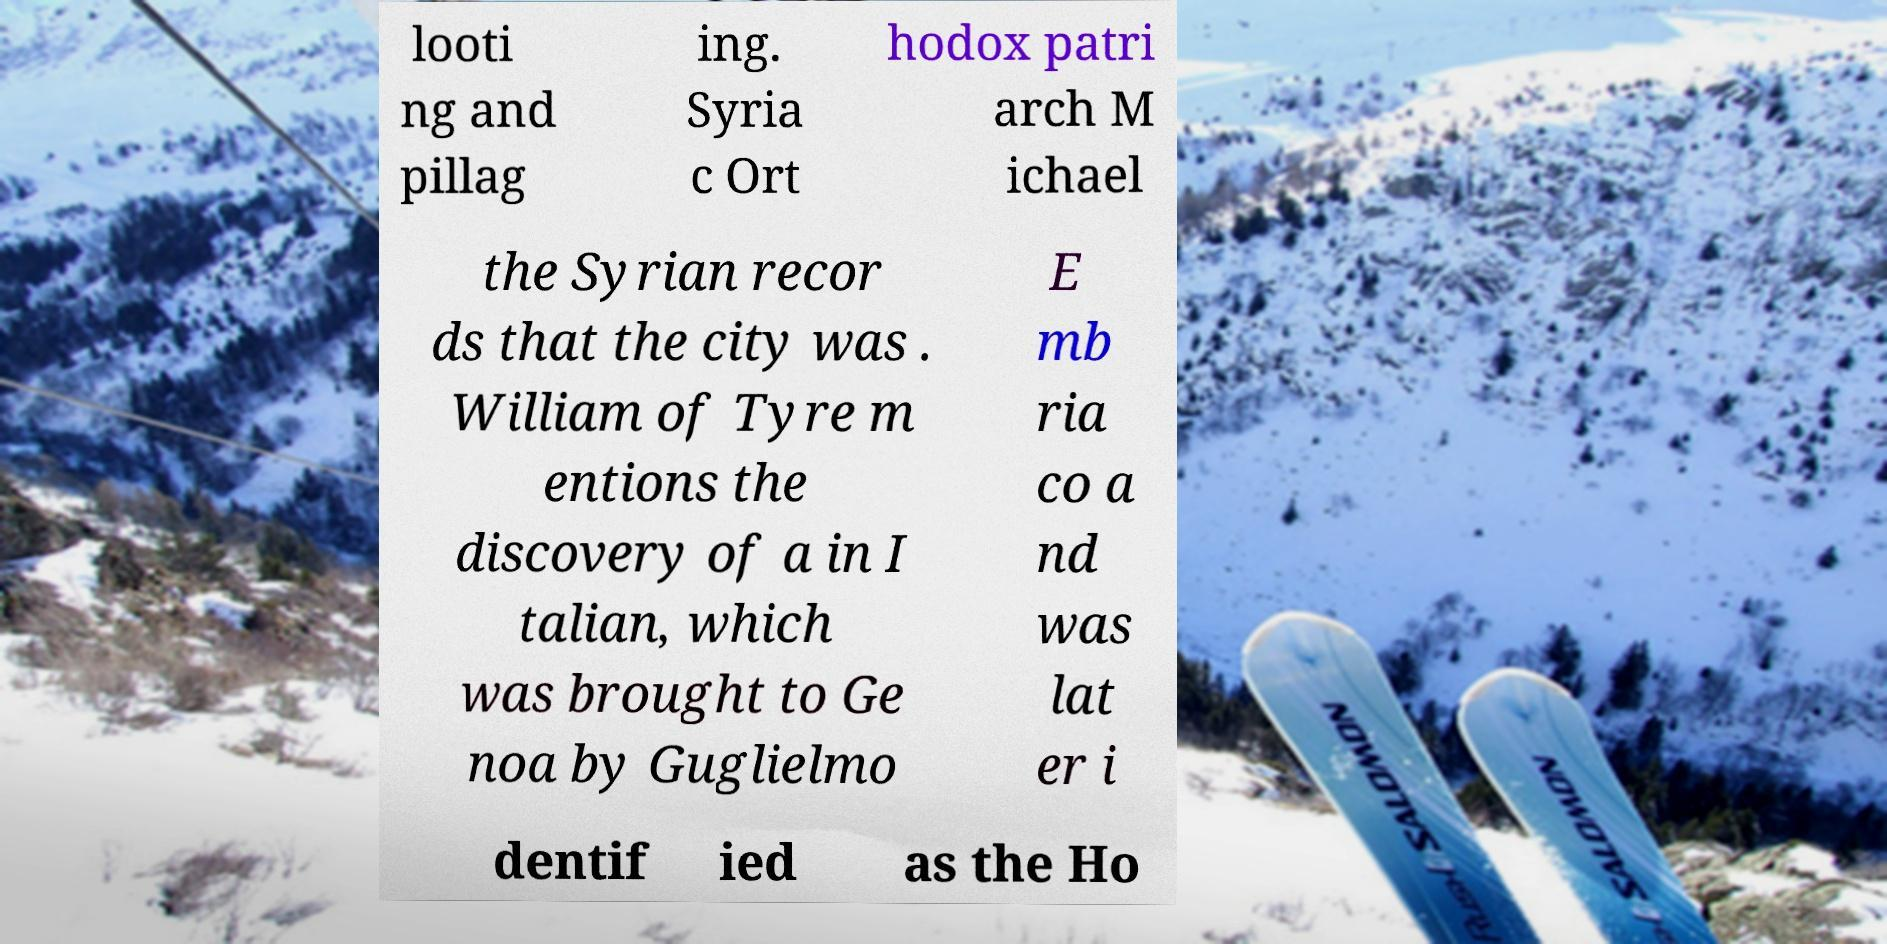For documentation purposes, I need the text within this image transcribed. Could you provide that? looti ng and pillag ing. Syria c Ort hodox patri arch M ichael the Syrian recor ds that the city was . William of Tyre m entions the discovery of a in I talian, which was brought to Ge noa by Guglielmo E mb ria co a nd was lat er i dentif ied as the Ho 